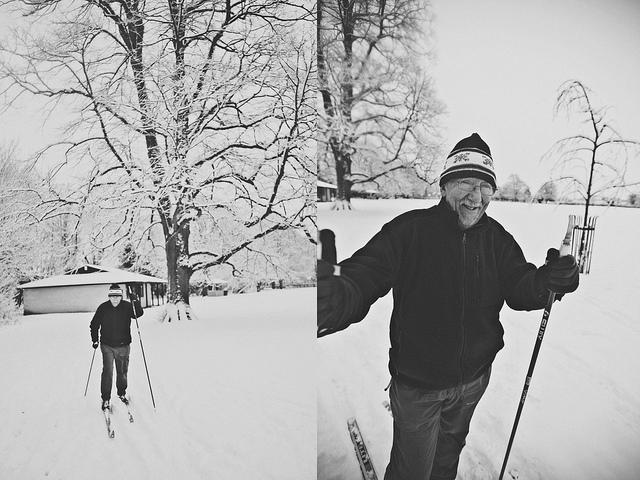Is this a residential backyard?
Answer briefly. Yes. What is on the man's face?
Short answer required. Glasses. Is the man a kid?
Be succinct. No. What color are these people wearing?
Keep it brief. Black. Where was this photo taken?
Answer briefly. Country. Is the person a man or woman?
Be succinct. Man. 